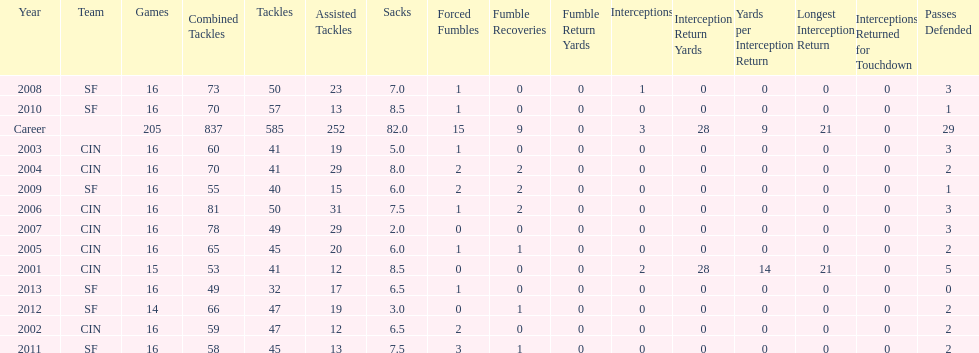Over how many continuous years were 20 or more assisted tackles recorded? 5. 